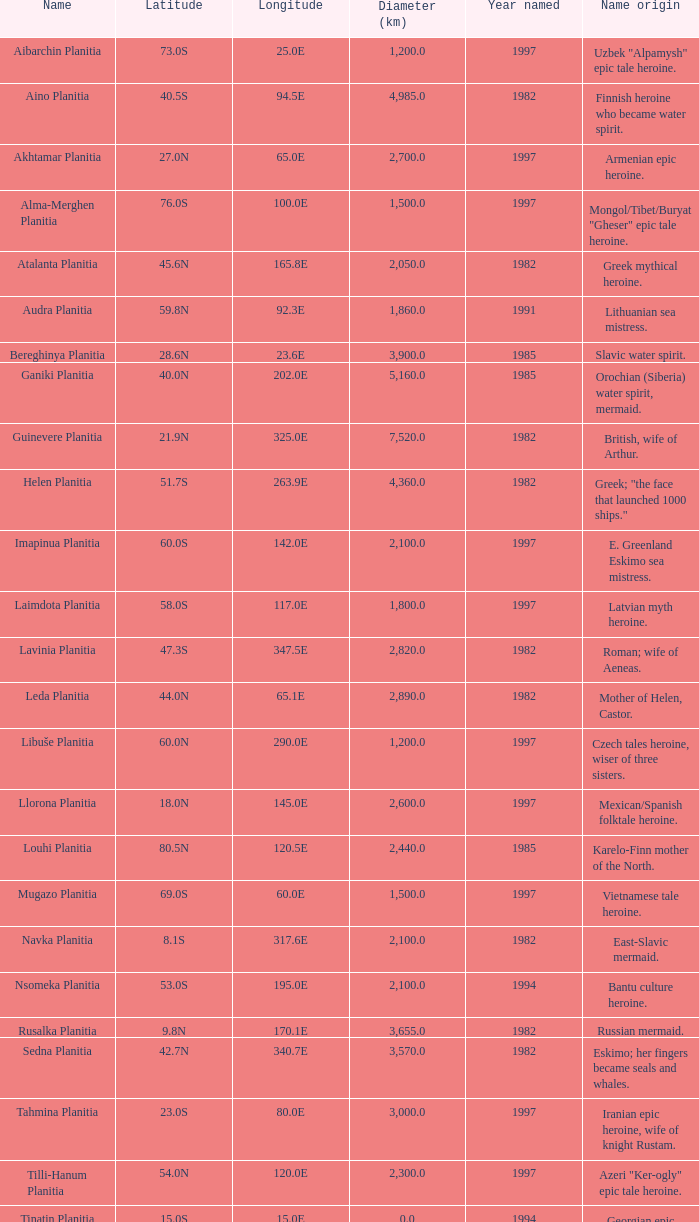Where does the name come from for the 2,155.0-kilometer diameter feature? Karelo-Finn mermaid. 